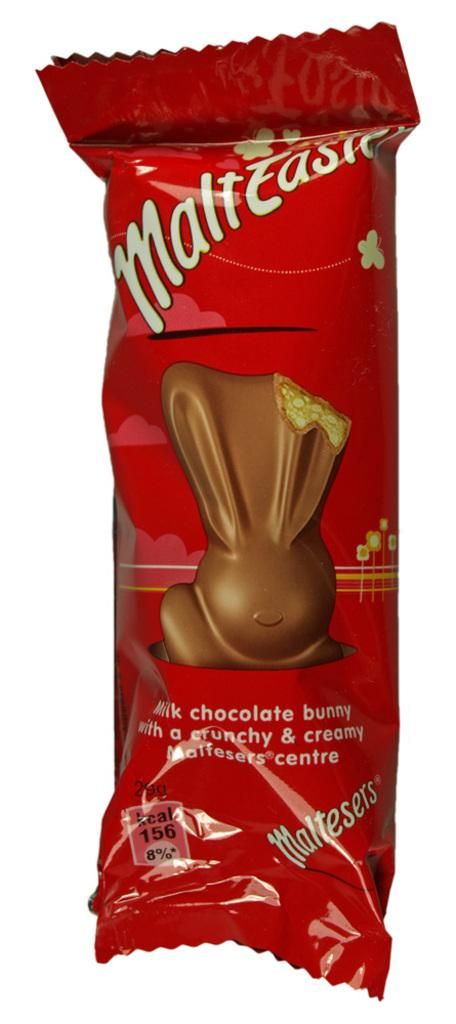What type of food item is visible in the image? There is a sealed chocolate in the image. What type of cub is playing with the chocolate in the image? There is no cub or any other animal present in the image; it only features a sealed chocolate. 